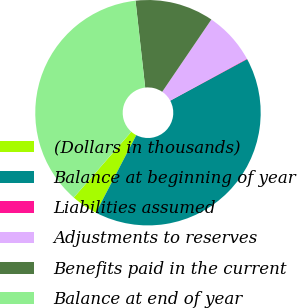<chart> <loc_0><loc_0><loc_500><loc_500><pie_chart><fcel>(Dollars in thousands)<fcel>Balance at beginning of year<fcel>Liabilities assumed<fcel>Adjustments to reserves<fcel>Benefits paid in the current<fcel>Balance at end of year<nl><fcel>3.8%<fcel>40.53%<fcel>0.07%<fcel>7.54%<fcel>11.27%<fcel>36.8%<nl></chart> 